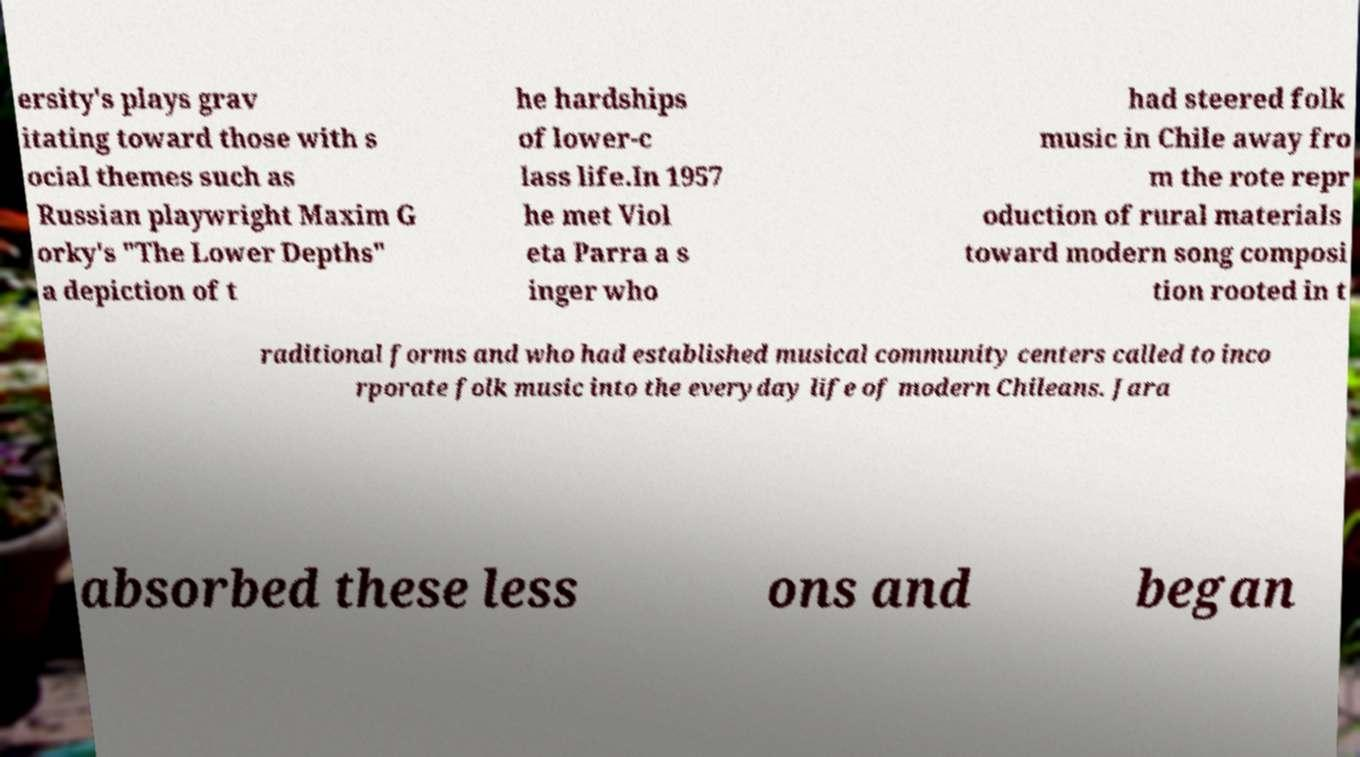For documentation purposes, I need the text within this image transcribed. Could you provide that? ersity's plays grav itating toward those with s ocial themes such as Russian playwright Maxim G orky's "The Lower Depths" a depiction of t he hardships of lower-c lass life.In 1957 he met Viol eta Parra a s inger who had steered folk music in Chile away fro m the rote repr oduction of rural materials toward modern song composi tion rooted in t raditional forms and who had established musical community centers called to inco rporate folk music into the everyday life of modern Chileans. Jara absorbed these less ons and began 